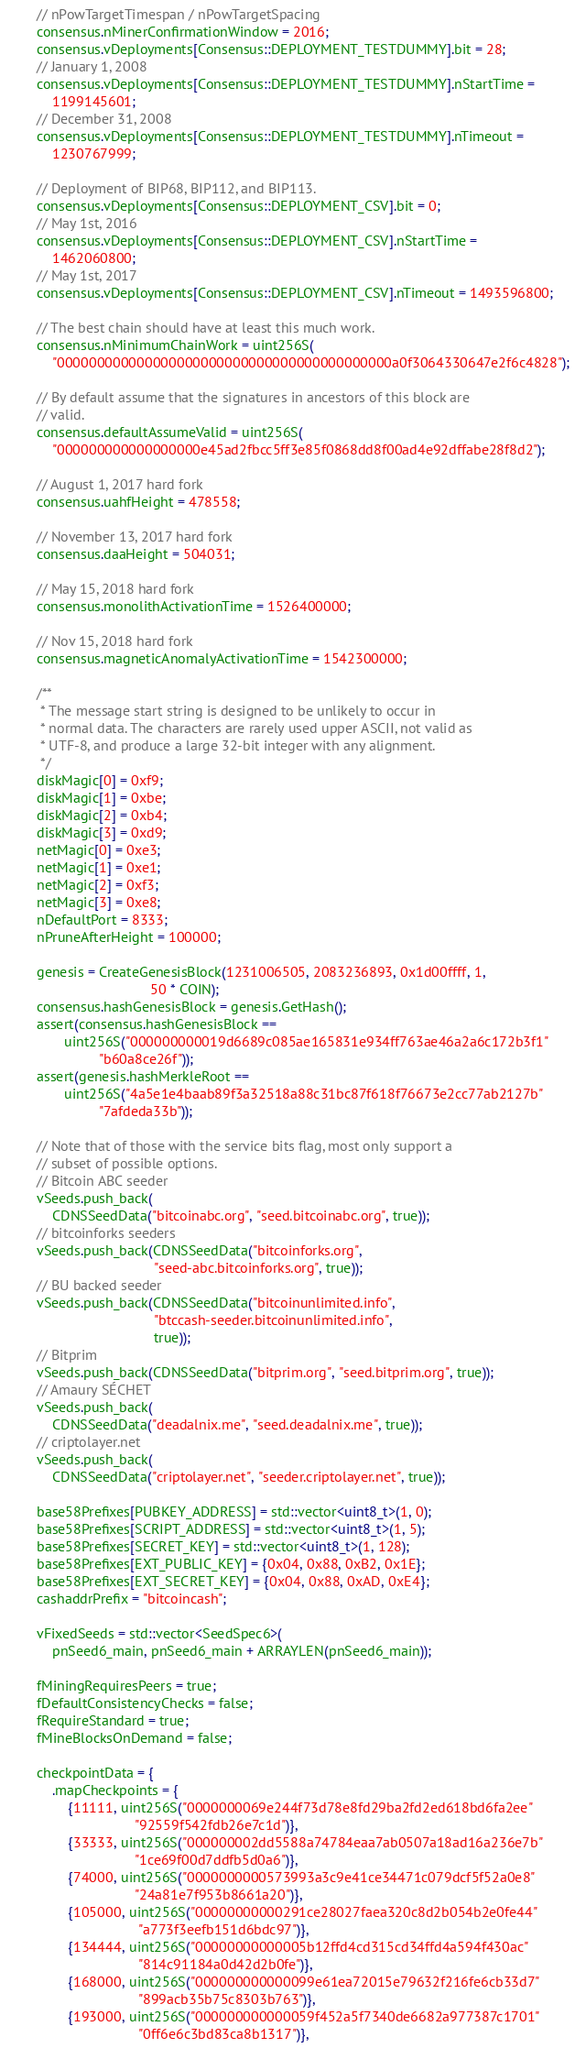Convert code to text. <code><loc_0><loc_0><loc_500><loc_500><_C++_>        // nPowTargetTimespan / nPowTargetSpacing
        consensus.nMinerConfirmationWindow = 2016;
        consensus.vDeployments[Consensus::DEPLOYMENT_TESTDUMMY].bit = 28;
        // January 1, 2008
        consensus.vDeployments[Consensus::DEPLOYMENT_TESTDUMMY].nStartTime =
            1199145601;
        // December 31, 2008
        consensus.vDeployments[Consensus::DEPLOYMENT_TESTDUMMY].nTimeout =
            1230767999;

        // Deployment of BIP68, BIP112, and BIP113.
        consensus.vDeployments[Consensus::DEPLOYMENT_CSV].bit = 0;
        // May 1st, 2016
        consensus.vDeployments[Consensus::DEPLOYMENT_CSV].nStartTime =
            1462060800;
        // May 1st, 2017
        consensus.vDeployments[Consensus::DEPLOYMENT_CSV].nTimeout = 1493596800;

        // The best chain should have at least this much work.
        consensus.nMinimumChainWork = uint256S(
            "000000000000000000000000000000000000000000a0f3064330647e2f6c4828");

        // By default assume that the signatures in ancestors of this block are
        // valid.
        consensus.defaultAssumeValid = uint256S(
            "000000000000000000e45ad2fbcc5ff3e85f0868dd8f00ad4e92dffabe28f8d2");

        // August 1, 2017 hard fork
        consensus.uahfHeight = 478558;

        // November 13, 2017 hard fork
        consensus.daaHeight = 504031;

        // May 15, 2018 hard fork
        consensus.monolithActivationTime = 1526400000;

        // Nov 15, 2018 hard fork
        consensus.magneticAnomalyActivationTime = 1542300000;

        /**
         * The message start string is designed to be unlikely to occur in
         * normal data. The characters are rarely used upper ASCII, not valid as
         * UTF-8, and produce a large 32-bit integer with any alignment.
         */
        diskMagic[0] = 0xf9;
        diskMagic[1] = 0xbe;
        diskMagic[2] = 0xb4;
        diskMagic[3] = 0xd9;
        netMagic[0] = 0xe3;
        netMagic[1] = 0xe1;
        netMagic[2] = 0xf3;
        netMagic[3] = 0xe8;
        nDefaultPort = 8333;
        nPruneAfterHeight = 100000;

        genesis = CreateGenesisBlock(1231006505, 2083236893, 0x1d00ffff, 1,
                                     50 * COIN);
        consensus.hashGenesisBlock = genesis.GetHash();
        assert(consensus.hashGenesisBlock ==
               uint256S("000000000019d6689c085ae165831e934ff763ae46a2a6c172b3f1"
                        "b60a8ce26f"));
        assert(genesis.hashMerkleRoot ==
               uint256S("4a5e1e4baab89f3a32518a88c31bc87f618f76673e2cc77ab2127b"
                        "7afdeda33b"));

        // Note that of those with the service bits flag, most only support a
        // subset of possible options.
        // Bitcoin ABC seeder
        vSeeds.push_back(
            CDNSSeedData("bitcoinabc.org", "seed.bitcoinabc.org", true));
        // bitcoinforks seeders
        vSeeds.push_back(CDNSSeedData("bitcoinforks.org",
                                      "seed-abc.bitcoinforks.org", true));
        // BU backed seeder
        vSeeds.push_back(CDNSSeedData("bitcoinunlimited.info",
                                      "btccash-seeder.bitcoinunlimited.info",
                                      true));
        // Bitprim
        vSeeds.push_back(CDNSSeedData("bitprim.org", "seed.bitprim.org", true));
        // Amaury SÉCHET
        vSeeds.push_back(
            CDNSSeedData("deadalnix.me", "seed.deadalnix.me", true));
        // criptolayer.net
        vSeeds.push_back(
            CDNSSeedData("criptolayer.net", "seeder.criptolayer.net", true));

        base58Prefixes[PUBKEY_ADDRESS] = std::vector<uint8_t>(1, 0);
        base58Prefixes[SCRIPT_ADDRESS] = std::vector<uint8_t>(1, 5);
        base58Prefixes[SECRET_KEY] = std::vector<uint8_t>(1, 128);
        base58Prefixes[EXT_PUBLIC_KEY] = {0x04, 0x88, 0xB2, 0x1E};
        base58Prefixes[EXT_SECRET_KEY] = {0x04, 0x88, 0xAD, 0xE4};
        cashaddrPrefix = "bitcoincash";

        vFixedSeeds = std::vector<SeedSpec6>(
            pnSeed6_main, pnSeed6_main + ARRAYLEN(pnSeed6_main));

        fMiningRequiresPeers = true;
        fDefaultConsistencyChecks = false;
        fRequireStandard = true;
        fMineBlocksOnDemand = false;

        checkpointData = {
            .mapCheckpoints = {
                {11111, uint256S("0000000069e244f73d78e8fd29ba2fd2ed618bd6fa2ee"
                                 "92559f542fdb26e7c1d")},
                {33333, uint256S("000000002dd5588a74784eaa7ab0507a18ad16a236e7b"
                                 "1ce69f00d7ddfb5d0a6")},
                {74000, uint256S("0000000000573993a3c9e41ce34471c079dcf5f52a0e8"
                                 "24a81e7f953b8661a20")},
                {105000, uint256S("00000000000291ce28027faea320c8d2b054b2e0fe44"
                                  "a773f3eefb151d6bdc97")},
                {134444, uint256S("00000000000005b12ffd4cd315cd34ffd4a594f430ac"
                                  "814c91184a0d42d2b0fe")},
                {168000, uint256S("000000000000099e61ea72015e79632f216fe6cb33d7"
                                  "899acb35b75c8303b763")},
                {193000, uint256S("000000000000059f452a5f7340de6682a977387c1701"
                                  "0ff6e6c3bd83ca8b1317")},</code> 